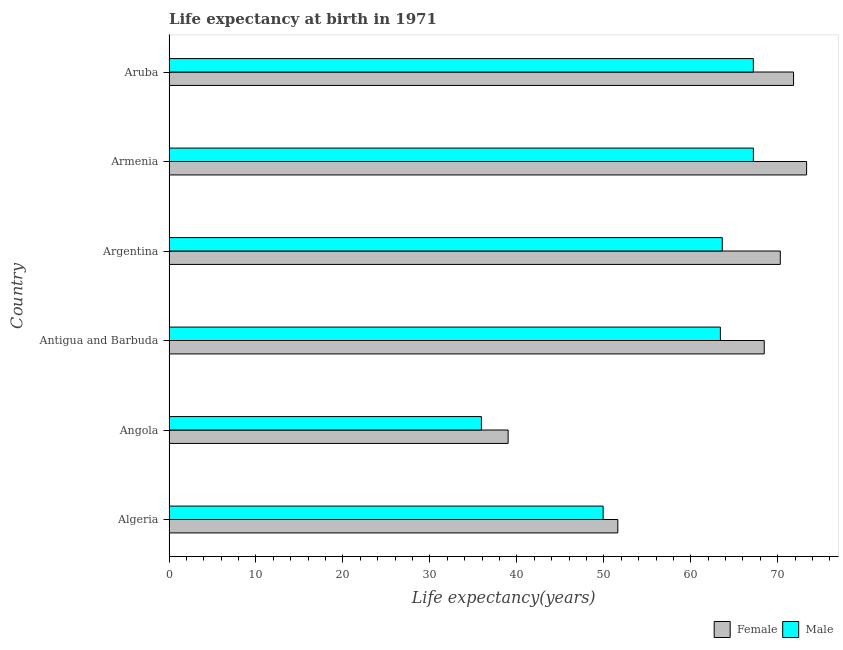How many different coloured bars are there?
Your response must be concise. 2. How many groups of bars are there?
Give a very brief answer. 6. Are the number of bars per tick equal to the number of legend labels?
Provide a short and direct response. Yes. Are the number of bars on each tick of the Y-axis equal?
Keep it short and to the point. Yes. How many bars are there on the 3rd tick from the top?
Give a very brief answer. 2. How many bars are there on the 6th tick from the bottom?
Give a very brief answer. 2. What is the label of the 1st group of bars from the top?
Make the answer very short. Aruba. What is the life expectancy(male) in Algeria?
Keep it short and to the point. 49.92. Across all countries, what is the maximum life expectancy(female)?
Provide a short and direct response. 73.32. Across all countries, what is the minimum life expectancy(female)?
Give a very brief answer. 38.99. In which country was the life expectancy(male) maximum?
Offer a very short reply. Armenia. In which country was the life expectancy(male) minimum?
Give a very brief answer. Angola. What is the total life expectancy(female) in the graph?
Your response must be concise. 374.47. What is the difference between the life expectancy(male) in Antigua and Barbuda and that in Argentina?
Your response must be concise. -0.21. What is the difference between the life expectancy(female) in Argentina and the life expectancy(male) in Aruba?
Your response must be concise. 3.1. What is the average life expectancy(female) per country?
Offer a very short reply. 62.41. What is the difference between the life expectancy(female) and life expectancy(male) in Angola?
Your response must be concise. 3.07. What is the ratio of the life expectancy(female) in Algeria to that in Aruba?
Offer a very short reply. 0.72. Is the life expectancy(female) in Algeria less than that in Argentina?
Ensure brevity in your answer.  Yes. What is the difference between the highest and the second highest life expectancy(female)?
Your answer should be compact. 1.5. What is the difference between the highest and the lowest life expectancy(male)?
Offer a terse response. 31.28. In how many countries, is the life expectancy(male) greater than the average life expectancy(male) taken over all countries?
Make the answer very short. 4. What does the 2nd bar from the top in Antigua and Barbuda represents?
Your answer should be compact. Female. How many bars are there?
Ensure brevity in your answer.  12. How many countries are there in the graph?
Give a very brief answer. 6. What is the difference between two consecutive major ticks on the X-axis?
Provide a succinct answer. 10. Does the graph contain grids?
Ensure brevity in your answer.  No. How many legend labels are there?
Provide a succinct answer. 2. How are the legend labels stacked?
Offer a terse response. Horizontal. What is the title of the graph?
Offer a terse response. Life expectancy at birth in 1971. What is the label or title of the X-axis?
Give a very brief answer. Life expectancy(years). What is the label or title of the Y-axis?
Your answer should be compact. Country. What is the Life expectancy(years) of Female in Algeria?
Keep it short and to the point. 51.61. What is the Life expectancy(years) in Male in Algeria?
Make the answer very short. 49.92. What is the Life expectancy(years) in Female in Angola?
Make the answer very short. 38.99. What is the Life expectancy(years) of Male in Angola?
Your answer should be compact. 35.92. What is the Life expectancy(years) of Female in Antigua and Barbuda?
Offer a terse response. 68.44. What is the Life expectancy(years) in Male in Antigua and Barbuda?
Make the answer very short. 63.4. What is the Life expectancy(years) of Female in Argentina?
Your answer should be very brief. 70.29. What is the Life expectancy(years) in Male in Argentina?
Your answer should be compact. 63.62. What is the Life expectancy(years) of Female in Armenia?
Provide a short and direct response. 73.32. What is the Life expectancy(years) in Male in Armenia?
Provide a short and direct response. 67.2. What is the Life expectancy(years) in Female in Aruba?
Provide a succinct answer. 71.81. What is the Life expectancy(years) in Male in Aruba?
Offer a terse response. 67.19. Across all countries, what is the maximum Life expectancy(years) in Female?
Give a very brief answer. 73.32. Across all countries, what is the maximum Life expectancy(years) of Male?
Ensure brevity in your answer.  67.2. Across all countries, what is the minimum Life expectancy(years) in Female?
Provide a short and direct response. 38.99. Across all countries, what is the minimum Life expectancy(years) in Male?
Your answer should be compact. 35.92. What is the total Life expectancy(years) in Female in the graph?
Provide a short and direct response. 374.47. What is the total Life expectancy(years) in Male in the graph?
Your answer should be compact. 347.25. What is the difference between the Life expectancy(years) in Female in Algeria and that in Angola?
Ensure brevity in your answer.  12.61. What is the difference between the Life expectancy(years) in Male in Algeria and that in Angola?
Make the answer very short. 14. What is the difference between the Life expectancy(years) in Female in Algeria and that in Antigua and Barbuda?
Your response must be concise. -16.84. What is the difference between the Life expectancy(years) in Male in Algeria and that in Antigua and Barbuda?
Provide a short and direct response. -13.48. What is the difference between the Life expectancy(years) in Female in Algeria and that in Argentina?
Give a very brief answer. -18.68. What is the difference between the Life expectancy(years) of Male in Algeria and that in Argentina?
Offer a terse response. -13.7. What is the difference between the Life expectancy(years) of Female in Algeria and that in Armenia?
Provide a short and direct response. -21.71. What is the difference between the Life expectancy(years) of Male in Algeria and that in Armenia?
Offer a terse response. -17.28. What is the difference between the Life expectancy(years) in Female in Algeria and that in Aruba?
Your response must be concise. -20.21. What is the difference between the Life expectancy(years) in Male in Algeria and that in Aruba?
Keep it short and to the point. -17.27. What is the difference between the Life expectancy(years) in Female in Angola and that in Antigua and Barbuda?
Keep it short and to the point. -29.45. What is the difference between the Life expectancy(years) in Male in Angola and that in Antigua and Barbuda?
Your response must be concise. -27.48. What is the difference between the Life expectancy(years) of Female in Angola and that in Argentina?
Your answer should be very brief. -31.3. What is the difference between the Life expectancy(years) of Male in Angola and that in Argentina?
Your response must be concise. -27.7. What is the difference between the Life expectancy(years) of Female in Angola and that in Armenia?
Make the answer very short. -34.32. What is the difference between the Life expectancy(years) of Male in Angola and that in Armenia?
Your response must be concise. -31.28. What is the difference between the Life expectancy(years) in Female in Angola and that in Aruba?
Give a very brief answer. -32.82. What is the difference between the Life expectancy(years) in Male in Angola and that in Aruba?
Your answer should be very brief. -31.27. What is the difference between the Life expectancy(years) in Female in Antigua and Barbuda and that in Argentina?
Your answer should be very brief. -1.85. What is the difference between the Life expectancy(years) of Male in Antigua and Barbuda and that in Argentina?
Provide a short and direct response. -0.21. What is the difference between the Life expectancy(years) of Female in Antigua and Barbuda and that in Armenia?
Your response must be concise. -4.87. What is the difference between the Life expectancy(years) in Male in Antigua and Barbuda and that in Armenia?
Keep it short and to the point. -3.79. What is the difference between the Life expectancy(years) in Female in Antigua and Barbuda and that in Aruba?
Make the answer very short. -3.37. What is the difference between the Life expectancy(years) of Male in Antigua and Barbuda and that in Aruba?
Provide a short and direct response. -3.79. What is the difference between the Life expectancy(years) in Female in Argentina and that in Armenia?
Offer a terse response. -3.03. What is the difference between the Life expectancy(years) of Male in Argentina and that in Armenia?
Offer a very short reply. -3.58. What is the difference between the Life expectancy(years) of Female in Argentina and that in Aruba?
Offer a terse response. -1.52. What is the difference between the Life expectancy(years) of Male in Argentina and that in Aruba?
Provide a short and direct response. -3.57. What is the difference between the Life expectancy(years) in Female in Armenia and that in Aruba?
Ensure brevity in your answer.  1.5. What is the difference between the Life expectancy(years) of Male in Armenia and that in Aruba?
Offer a very short reply. 0.01. What is the difference between the Life expectancy(years) in Female in Algeria and the Life expectancy(years) in Male in Angola?
Provide a succinct answer. 15.69. What is the difference between the Life expectancy(years) in Female in Algeria and the Life expectancy(years) in Male in Antigua and Barbuda?
Ensure brevity in your answer.  -11.79. What is the difference between the Life expectancy(years) of Female in Algeria and the Life expectancy(years) of Male in Argentina?
Your answer should be compact. -12.01. What is the difference between the Life expectancy(years) of Female in Algeria and the Life expectancy(years) of Male in Armenia?
Your response must be concise. -15.59. What is the difference between the Life expectancy(years) in Female in Algeria and the Life expectancy(years) in Male in Aruba?
Provide a succinct answer. -15.58. What is the difference between the Life expectancy(years) of Female in Angola and the Life expectancy(years) of Male in Antigua and Barbuda?
Your answer should be compact. -24.41. What is the difference between the Life expectancy(years) of Female in Angola and the Life expectancy(years) of Male in Argentina?
Provide a succinct answer. -24.62. What is the difference between the Life expectancy(years) in Female in Angola and the Life expectancy(years) in Male in Armenia?
Offer a very short reply. -28.2. What is the difference between the Life expectancy(years) of Female in Angola and the Life expectancy(years) of Male in Aruba?
Make the answer very short. -28.2. What is the difference between the Life expectancy(years) in Female in Antigua and Barbuda and the Life expectancy(years) in Male in Argentina?
Give a very brief answer. 4.83. What is the difference between the Life expectancy(years) of Female in Antigua and Barbuda and the Life expectancy(years) of Male in Armenia?
Provide a short and direct response. 1.25. What is the difference between the Life expectancy(years) in Female in Antigua and Barbuda and the Life expectancy(years) in Male in Aruba?
Your response must be concise. 1.25. What is the difference between the Life expectancy(years) of Female in Argentina and the Life expectancy(years) of Male in Armenia?
Offer a terse response. 3.09. What is the difference between the Life expectancy(years) of Female in Argentina and the Life expectancy(years) of Male in Aruba?
Keep it short and to the point. 3.1. What is the difference between the Life expectancy(years) of Female in Armenia and the Life expectancy(years) of Male in Aruba?
Ensure brevity in your answer.  6.13. What is the average Life expectancy(years) in Female per country?
Your answer should be very brief. 62.41. What is the average Life expectancy(years) of Male per country?
Your answer should be compact. 57.88. What is the difference between the Life expectancy(years) in Female and Life expectancy(years) in Male in Algeria?
Your response must be concise. 1.69. What is the difference between the Life expectancy(years) in Female and Life expectancy(years) in Male in Angola?
Your answer should be compact. 3.07. What is the difference between the Life expectancy(years) in Female and Life expectancy(years) in Male in Antigua and Barbuda?
Your response must be concise. 5.04. What is the difference between the Life expectancy(years) of Female and Life expectancy(years) of Male in Argentina?
Ensure brevity in your answer.  6.67. What is the difference between the Life expectancy(years) in Female and Life expectancy(years) in Male in Armenia?
Keep it short and to the point. 6.12. What is the difference between the Life expectancy(years) of Female and Life expectancy(years) of Male in Aruba?
Make the answer very short. 4.62. What is the ratio of the Life expectancy(years) of Female in Algeria to that in Angola?
Provide a succinct answer. 1.32. What is the ratio of the Life expectancy(years) of Male in Algeria to that in Angola?
Your answer should be compact. 1.39. What is the ratio of the Life expectancy(years) of Female in Algeria to that in Antigua and Barbuda?
Keep it short and to the point. 0.75. What is the ratio of the Life expectancy(years) of Male in Algeria to that in Antigua and Barbuda?
Your response must be concise. 0.79. What is the ratio of the Life expectancy(years) of Female in Algeria to that in Argentina?
Offer a terse response. 0.73. What is the ratio of the Life expectancy(years) in Male in Algeria to that in Argentina?
Your answer should be very brief. 0.78. What is the ratio of the Life expectancy(years) of Female in Algeria to that in Armenia?
Ensure brevity in your answer.  0.7. What is the ratio of the Life expectancy(years) of Male in Algeria to that in Armenia?
Offer a very short reply. 0.74. What is the ratio of the Life expectancy(years) of Female in Algeria to that in Aruba?
Offer a terse response. 0.72. What is the ratio of the Life expectancy(years) in Male in Algeria to that in Aruba?
Provide a short and direct response. 0.74. What is the ratio of the Life expectancy(years) in Female in Angola to that in Antigua and Barbuda?
Your answer should be very brief. 0.57. What is the ratio of the Life expectancy(years) in Male in Angola to that in Antigua and Barbuda?
Your answer should be compact. 0.57. What is the ratio of the Life expectancy(years) of Female in Angola to that in Argentina?
Provide a succinct answer. 0.55. What is the ratio of the Life expectancy(years) of Male in Angola to that in Argentina?
Make the answer very short. 0.56. What is the ratio of the Life expectancy(years) in Female in Angola to that in Armenia?
Offer a terse response. 0.53. What is the ratio of the Life expectancy(years) of Male in Angola to that in Armenia?
Provide a succinct answer. 0.53. What is the ratio of the Life expectancy(years) in Female in Angola to that in Aruba?
Your answer should be compact. 0.54. What is the ratio of the Life expectancy(years) in Male in Angola to that in Aruba?
Your response must be concise. 0.53. What is the ratio of the Life expectancy(years) of Female in Antigua and Barbuda to that in Argentina?
Ensure brevity in your answer.  0.97. What is the ratio of the Life expectancy(years) of Female in Antigua and Barbuda to that in Armenia?
Your answer should be very brief. 0.93. What is the ratio of the Life expectancy(years) of Male in Antigua and Barbuda to that in Armenia?
Provide a succinct answer. 0.94. What is the ratio of the Life expectancy(years) in Female in Antigua and Barbuda to that in Aruba?
Offer a terse response. 0.95. What is the ratio of the Life expectancy(years) of Male in Antigua and Barbuda to that in Aruba?
Ensure brevity in your answer.  0.94. What is the ratio of the Life expectancy(years) in Female in Argentina to that in Armenia?
Offer a very short reply. 0.96. What is the ratio of the Life expectancy(years) of Male in Argentina to that in Armenia?
Your response must be concise. 0.95. What is the ratio of the Life expectancy(years) in Female in Argentina to that in Aruba?
Ensure brevity in your answer.  0.98. What is the ratio of the Life expectancy(years) in Male in Argentina to that in Aruba?
Make the answer very short. 0.95. What is the ratio of the Life expectancy(years) in Female in Armenia to that in Aruba?
Give a very brief answer. 1.02. What is the ratio of the Life expectancy(years) of Male in Armenia to that in Aruba?
Ensure brevity in your answer.  1. What is the difference between the highest and the second highest Life expectancy(years) in Female?
Your answer should be compact. 1.5. What is the difference between the highest and the second highest Life expectancy(years) of Male?
Your answer should be compact. 0.01. What is the difference between the highest and the lowest Life expectancy(years) in Female?
Keep it short and to the point. 34.32. What is the difference between the highest and the lowest Life expectancy(years) of Male?
Provide a succinct answer. 31.28. 